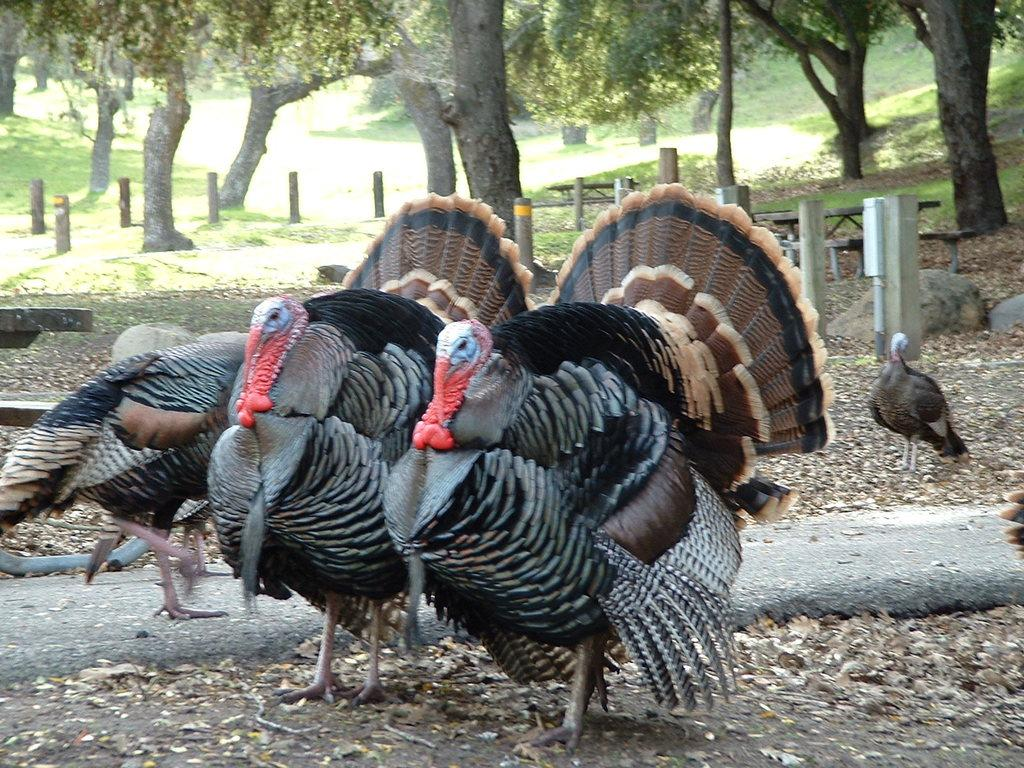What is located in the center of the image? There are birds in the center of the image. What can be seen in the background of the image? There are trees, poles, and benches in the background of the image. What is visible at the bottom of the image? There is ground visible at the bottom of the image. What decision is the building making in the image? There is no building present in the image, so no decision can be attributed to a building. 